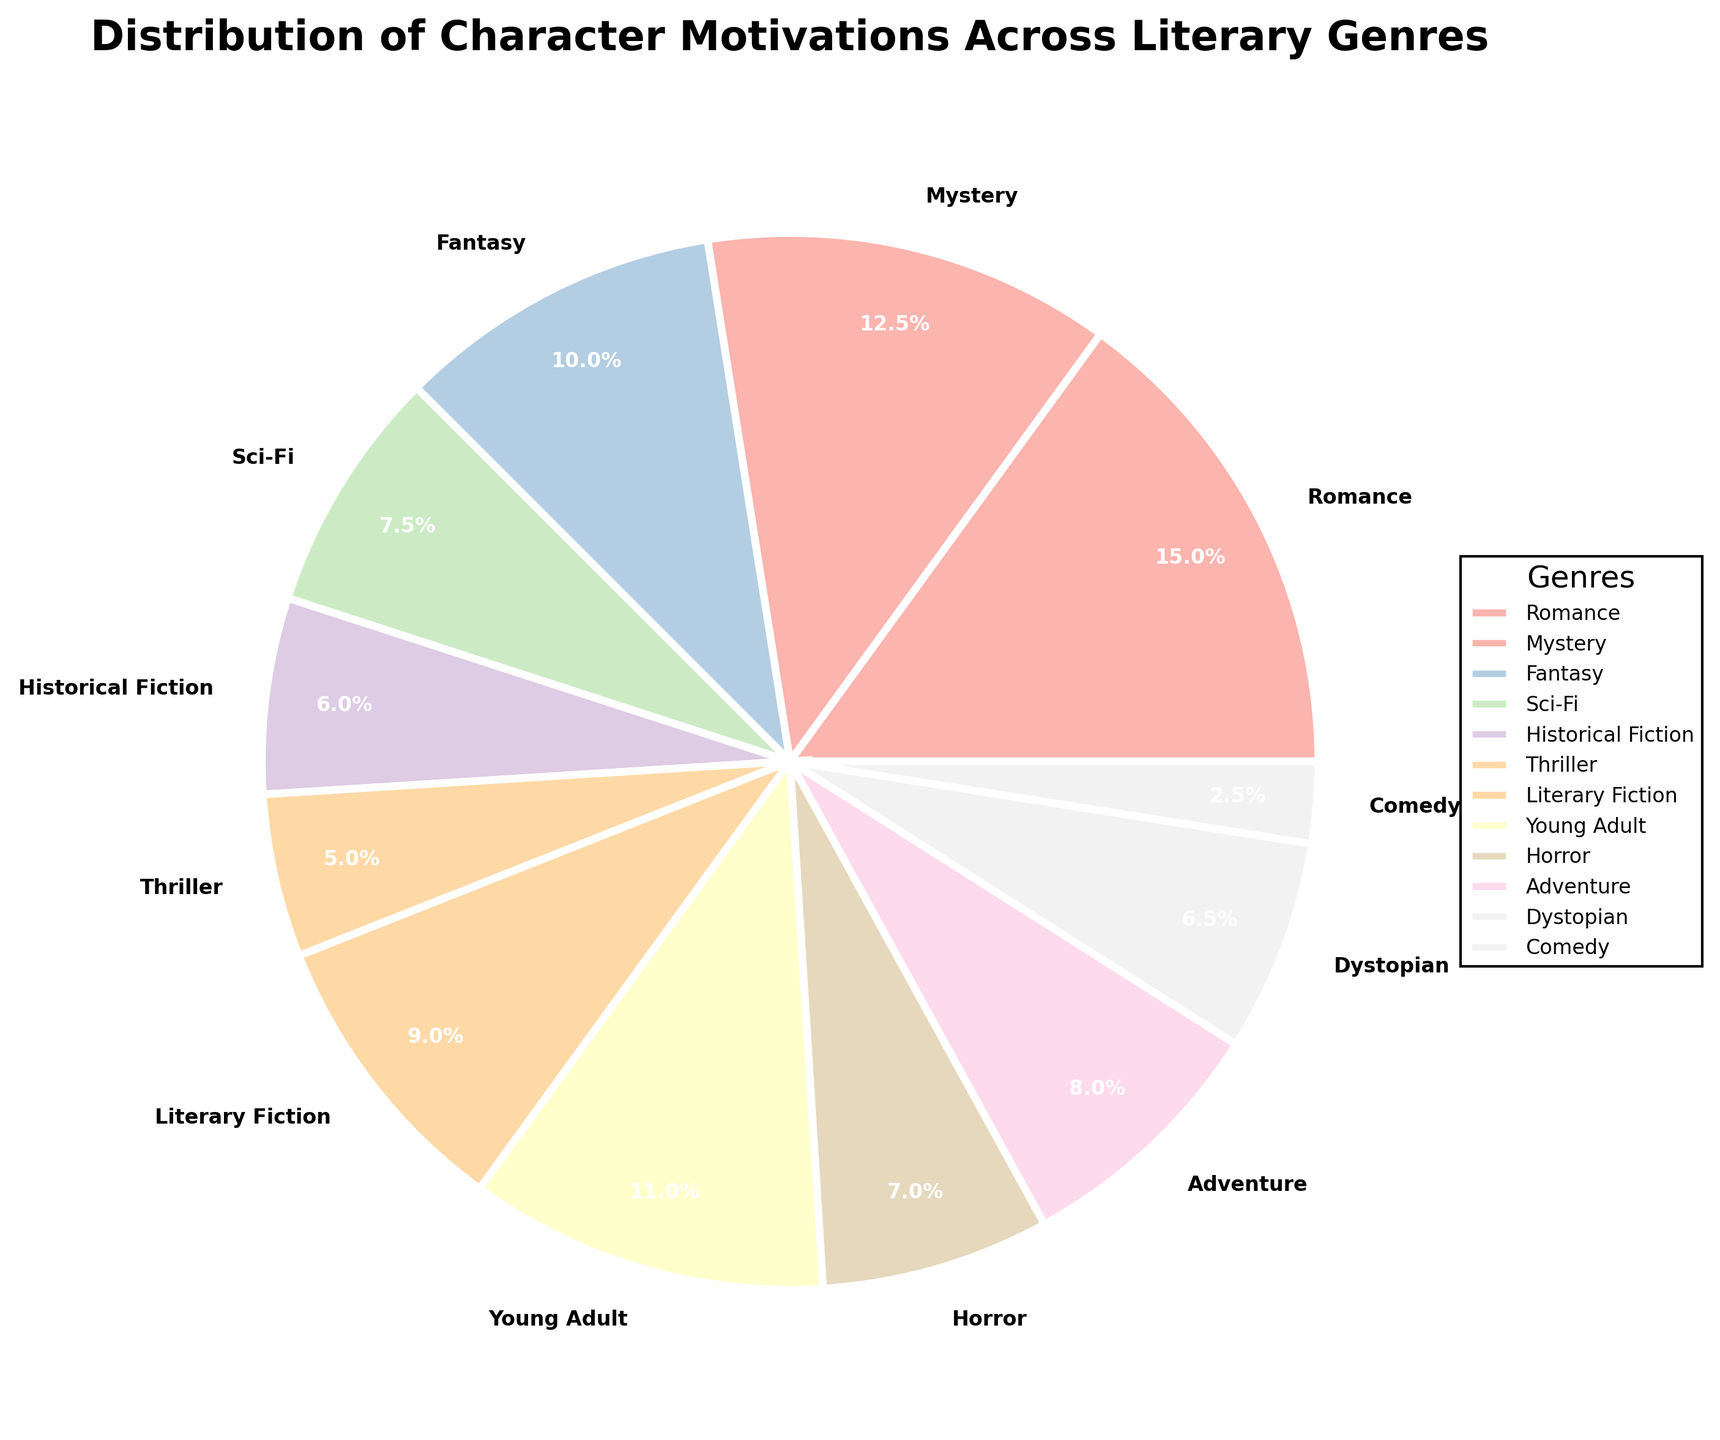What percentage of literary genres have a motivation related to personal achievement (e.g., Self-Discovery, Achieving Personal Success)? To find the percentage, look at the genres with motivations related to personal achievement, which include Literary Fiction (18%) and Comedy (5%). Summing these percentages: 18% + 5% = 23%.
Answer: 23% Which genre has a higher percentage of character motivations: Sci-Fi or Dystopian? To determine this, compare the percentages for Sci-Fi (15%) and Dystopian (13%). Sci-Fi has a higher percentage.
Answer: Sci-Fi What is the total percentage of character motivations related to overcoming obstacles or constraints (e.g., Overcoming Societal Constraints, Surviving a Threat)? These include Historical Fiction (12%) and Horror (14%). Summing these percentages: 12% + 14% = 26%.
Answer: 26% Which genre has the smallest percentage of character motivations? To identify this, look for the genre with the lowest percentage. Comedy has the smallest percentage at 5%.
Answer: Comedy How much larger is the percentage of Romance motivations compared to Thriller motivations? Romance has 30% and Thriller has 10%. The difference is 30% - 10% = 20%.
Answer: 20% Is the percentage of character motivations in Fantasy greater than or equal to the percentage in Adventure and Dystopian combined? Fantasy has 20%. Adventure (16%) and Dystopian (13%) combined equal 16% + 13% = 29%. Since 20% is less than 29%, the answer is no.
Answer: No Which genre has character motivations related to exploring, either by new worlds or seeking treasure? Sci-Fi (Exploring New Worlds) has 15% and Adventure (Seeking Treasure or Glory) has 16%. Summing these gives 15% + 16% = 31%.
Answer: Sci-Fi and Adventure Among Mystery and Young Adult genres, which has the greater percentage, and by how much? Mystery has 25% and Young Adult has 22%. The difference is 25% - 22% = 3%.
Answer: Mystery by 3% What's the combined percentage of genres related to achieving something positive (e.g., Finding True Love, Coming of Age, Achieving Personal Success)? These genres are Romance (30%), Young Adult (22%), and Comedy (5%). Summing these percentages: 30% + 22% + 5% = 57%.
Answer: 57% 